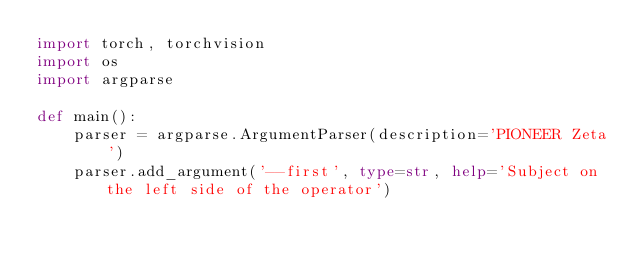Convert code to text. <code><loc_0><loc_0><loc_500><loc_500><_Python_>import torch, torchvision
import os
import argparse

def main():
	parser = argparse.ArgumentParser(description='PIONEER Zeta')
	parser.add_argument('--first', type=str, help='Subject on the left side of the operator')
	</code> 